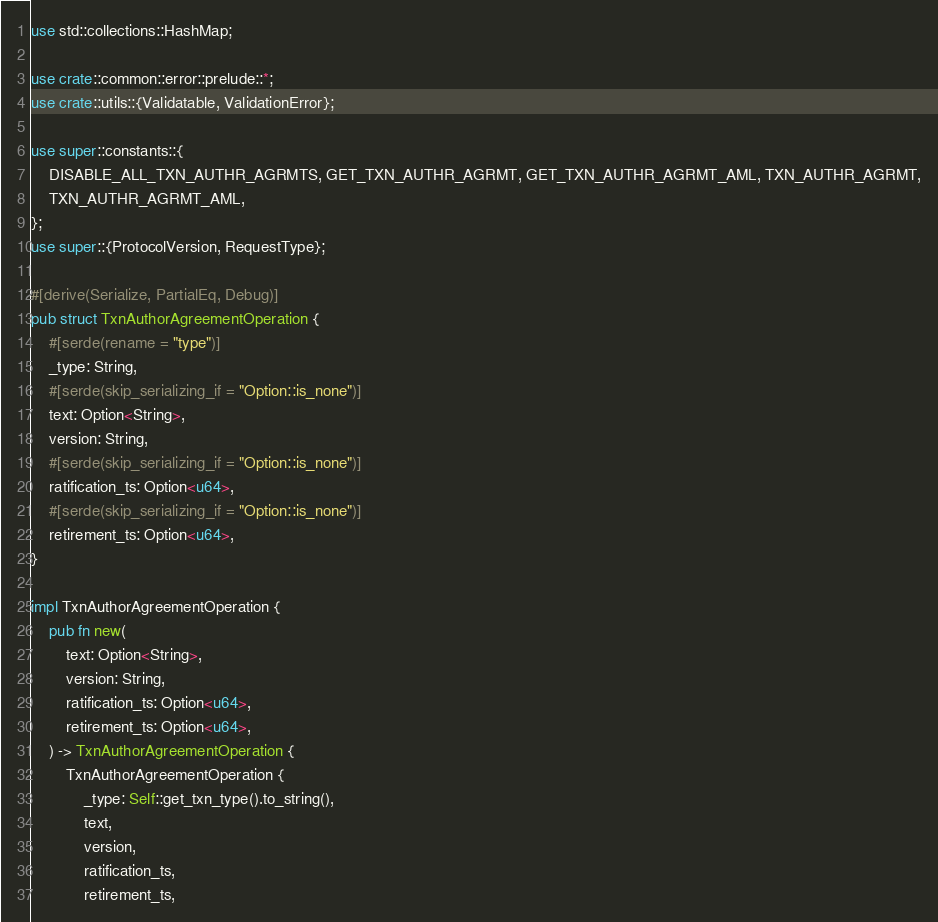<code> <loc_0><loc_0><loc_500><loc_500><_Rust_>use std::collections::HashMap;

use crate::common::error::prelude::*;
use crate::utils::{Validatable, ValidationError};

use super::constants::{
    DISABLE_ALL_TXN_AUTHR_AGRMTS, GET_TXN_AUTHR_AGRMT, GET_TXN_AUTHR_AGRMT_AML, TXN_AUTHR_AGRMT,
    TXN_AUTHR_AGRMT_AML,
};
use super::{ProtocolVersion, RequestType};

#[derive(Serialize, PartialEq, Debug)]
pub struct TxnAuthorAgreementOperation {
    #[serde(rename = "type")]
    _type: String,
    #[serde(skip_serializing_if = "Option::is_none")]
    text: Option<String>,
    version: String,
    #[serde(skip_serializing_if = "Option::is_none")]
    ratification_ts: Option<u64>,
    #[serde(skip_serializing_if = "Option::is_none")]
    retirement_ts: Option<u64>,
}

impl TxnAuthorAgreementOperation {
    pub fn new(
        text: Option<String>,
        version: String,
        ratification_ts: Option<u64>,
        retirement_ts: Option<u64>,
    ) -> TxnAuthorAgreementOperation {
        TxnAuthorAgreementOperation {
            _type: Self::get_txn_type().to_string(),
            text,
            version,
            ratification_ts,
            retirement_ts,</code> 